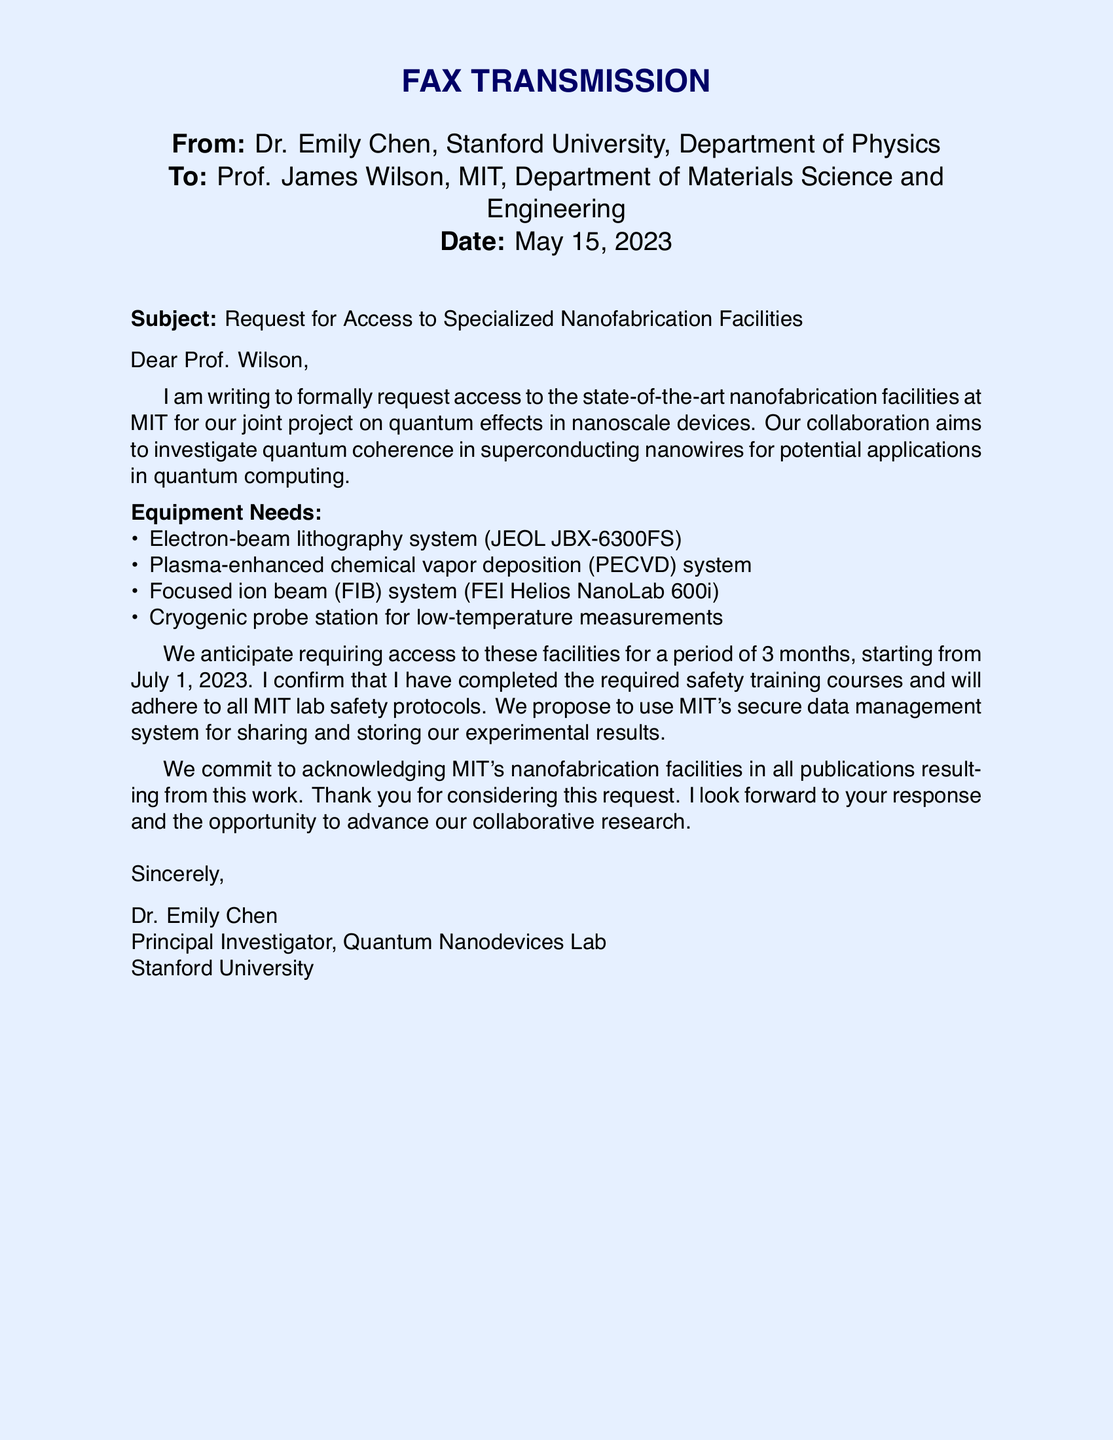What is the name of the sender? The sender is introduced in the document as Dr. Emily Chen.
Answer: Dr. Emily Chen Who is the recipient of the fax? The recipient is mentioned at the beginning of the document as Prof. James Wilson.
Answer: Prof. James Wilson What is the subject of the fax? The subject line in the fax states the purpose as requesting access to nanofabrication facilities.
Answer: Request for Access to Specialized Nanofabrication Facilities What equipment is required for the project? The document lists specific equipment needs for the project, including an electron-beam lithography system and others.
Answer: Electron-beam lithography system, PECVD system, FIB system, cryogenic probe station How long is access to the facilities requested? The fax indicates the duration of access that is being requested as three months.
Answer: 3 months What start date is mentioned for access? The document explicitly states the starting date for access is July 1, 2023.
Answer: July 1, 2023 What collaboration is being discussed in the fax? The collaboration mentioned focuses on quantum effects in nanoscale devices.
Answer: Quantum effects in nanoscale devices What safety protocols does Dr. Chen confirm to follow? The document mentions that Dr. Chen confirms adherence to all MIT lab safety protocols.
Answer: All MIT lab safety protocols What will be done with the experimental results? The document mentions using MIT's secure data management system for sharing and storing results.
Answer: MIT's secure data management system 